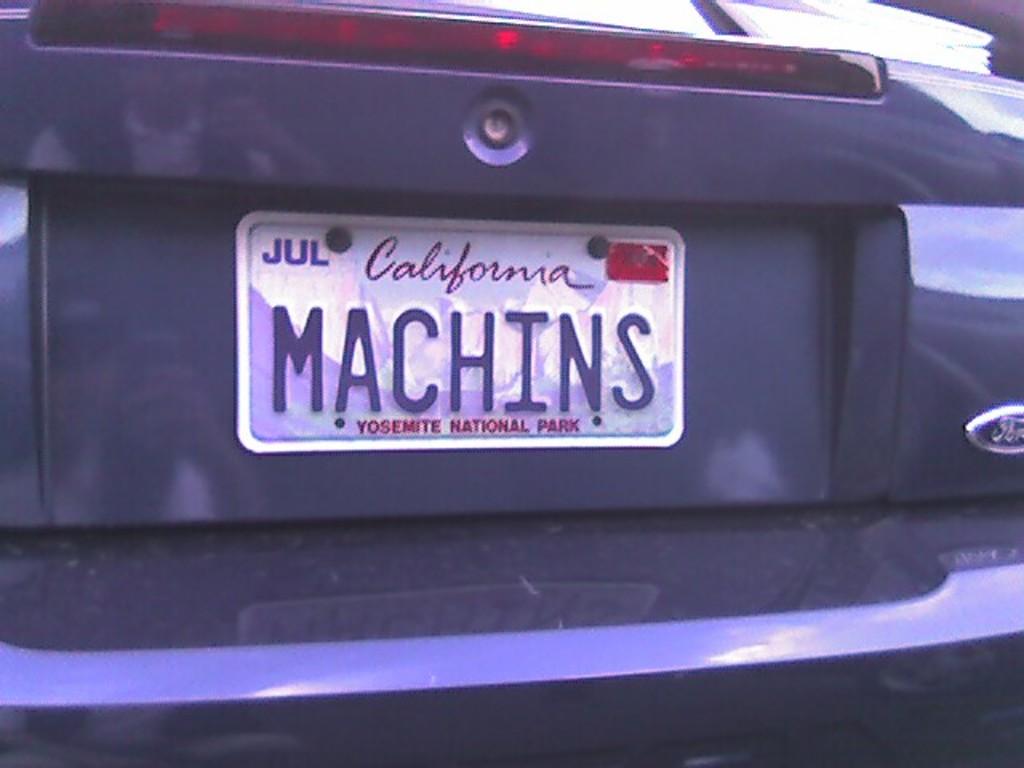Which state issued the license plate?
Provide a short and direct response. California. 